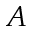<formula> <loc_0><loc_0><loc_500><loc_500>A</formula> 